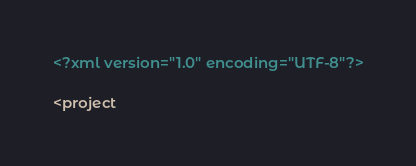Convert code to text. <code><loc_0><loc_0><loc_500><loc_500><_XML_><?xml version="1.0" encoding="UTF-8"?>

<project</code> 